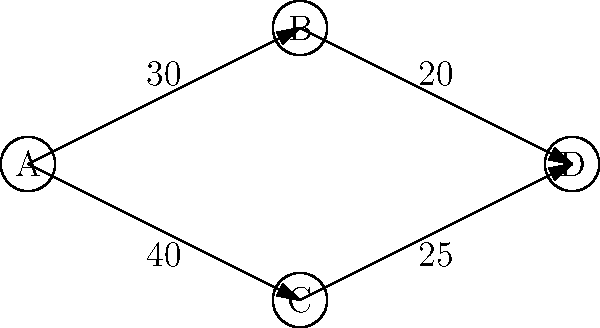In a luxury apartment complex, you need to design an efficient traffic flow system. The diagram represents different routes between key areas: A (main entrance), B (parking), C (residential towers), and D (amenities). The numbers on each path represent the average number of vehicles per hour. What is the maximum flow of vehicles from A to D, and which path(s) should be prioritized for expansion to improve overall traffic flow? To solve this problem, we'll use the max-flow min-cut theorem and the Ford-Fulkerson algorithm:

1. Identify the source (A) and sink (D) in the network.

2. Calculate the maximum flow:
   a) Path A -> B -> D: min(30, 20) = 20
   b) Path A -> C -> D: min(40, 25) = 25
   The maximum flow is the sum of these paths: 20 + 25 = 45 vehicles per hour

3. Identify the bottlenecks:
   a) B -> D with capacity 20
   b) C -> D with capacity 25

4. To improve overall traffic flow, we should prioritize expanding the path with the larger bottleneck, which is C -> D (25 vehicles per hour).

5. If we increase the capacity of C -> D, we can potentially increase the flow from A -> C -> D up to 40 vehicles per hour (limited by the capacity of A -> C).

6. After expanding C -> D, the new maximum flow would be:
   20 (via A -> B -> D) + 40 (via A -> C -> D) = 60 vehicles per hour

Therefore, prioritizing the expansion of path C -> D would yield the greatest improvement in overall traffic flow.
Answer: Maximum flow: 45 vehicles/hour. Prioritize expanding path C -> D. 